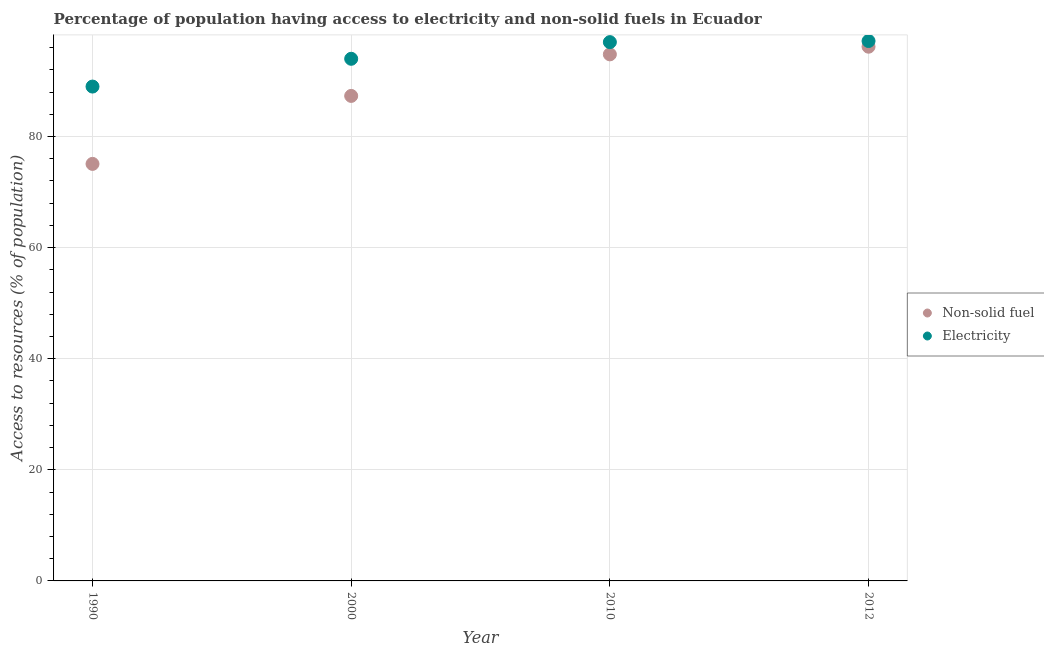How many different coloured dotlines are there?
Offer a terse response. 2. What is the percentage of population having access to non-solid fuel in 2010?
Offer a terse response. 94.8. Across all years, what is the maximum percentage of population having access to electricity?
Keep it short and to the point. 97.2. Across all years, what is the minimum percentage of population having access to electricity?
Your response must be concise. 89. In which year was the percentage of population having access to electricity maximum?
Your answer should be compact. 2012. What is the total percentage of population having access to electricity in the graph?
Offer a very short reply. 377.2. What is the difference between the percentage of population having access to non-solid fuel in 1990 and that in 2010?
Provide a succinct answer. -19.72. What is the difference between the percentage of population having access to non-solid fuel in 2010 and the percentage of population having access to electricity in 2012?
Your answer should be compact. -2.4. What is the average percentage of population having access to non-solid fuel per year?
Keep it short and to the point. 88.34. In the year 2012, what is the difference between the percentage of population having access to non-solid fuel and percentage of population having access to electricity?
Provide a succinct answer. -1.02. In how many years, is the percentage of population having access to non-solid fuel greater than 44 %?
Your response must be concise. 4. What is the ratio of the percentage of population having access to electricity in 1990 to that in 2000?
Offer a terse response. 0.95. Is the difference between the percentage of population having access to electricity in 1990 and 2010 greater than the difference between the percentage of population having access to non-solid fuel in 1990 and 2010?
Your answer should be very brief. Yes. What is the difference between the highest and the second highest percentage of population having access to non-solid fuel?
Offer a terse response. 1.38. What is the difference between the highest and the lowest percentage of population having access to electricity?
Give a very brief answer. 8.2. Is the sum of the percentage of population having access to electricity in 1990 and 2000 greater than the maximum percentage of population having access to non-solid fuel across all years?
Make the answer very short. Yes. Does the percentage of population having access to non-solid fuel monotonically increase over the years?
Offer a very short reply. Yes. Is the percentage of population having access to non-solid fuel strictly greater than the percentage of population having access to electricity over the years?
Provide a short and direct response. No. Is the percentage of population having access to electricity strictly less than the percentage of population having access to non-solid fuel over the years?
Offer a terse response. No. How many dotlines are there?
Your response must be concise. 2. How many years are there in the graph?
Offer a terse response. 4. Does the graph contain any zero values?
Offer a terse response. No. Where does the legend appear in the graph?
Offer a terse response. Center right. What is the title of the graph?
Provide a short and direct response. Percentage of population having access to electricity and non-solid fuels in Ecuador. What is the label or title of the X-axis?
Your answer should be compact. Year. What is the label or title of the Y-axis?
Your response must be concise. Access to resources (% of population). What is the Access to resources (% of population) in Non-solid fuel in 1990?
Your answer should be very brief. 75.08. What is the Access to resources (% of population) of Electricity in 1990?
Ensure brevity in your answer.  89. What is the Access to resources (% of population) of Non-solid fuel in 2000?
Provide a succinct answer. 87.32. What is the Access to resources (% of population) of Electricity in 2000?
Your response must be concise. 94. What is the Access to resources (% of population) in Non-solid fuel in 2010?
Your answer should be compact. 94.8. What is the Access to resources (% of population) in Electricity in 2010?
Provide a short and direct response. 97. What is the Access to resources (% of population) of Non-solid fuel in 2012?
Offer a terse response. 96.18. What is the Access to resources (% of population) in Electricity in 2012?
Provide a succinct answer. 97.2. Across all years, what is the maximum Access to resources (% of population) in Non-solid fuel?
Give a very brief answer. 96.18. Across all years, what is the maximum Access to resources (% of population) in Electricity?
Your response must be concise. 97.2. Across all years, what is the minimum Access to resources (% of population) in Non-solid fuel?
Your response must be concise. 75.08. Across all years, what is the minimum Access to resources (% of population) of Electricity?
Offer a very short reply. 89. What is the total Access to resources (% of population) in Non-solid fuel in the graph?
Your response must be concise. 353.37. What is the total Access to resources (% of population) in Electricity in the graph?
Give a very brief answer. 377.2. What is the difference between the Access to resources (% of population) of Non-solid fuel in 1990 and that in 2000?
Offer a terse response. -12.24. What is the difference between the Access to resources (% of population) of Non-solid fuel in 1990 and that in 2010?
Your answer should be compact. -19.72. What is the difference between the Access to resources (% of population) of Non-solid fuel in 1990 and that in 2012?
Keep it short and to the point. -21.1. What is the difference between the Access to resources (% of population) in Non-solid fuel in 2000 and that in 2010?
Give a very brief answer. -7.48. What is the difference between the Access to resources (% of population) in Non-solid fuel in 2000 and that in 2012?
Make the answer very short. -8.86. What is the difference between the Access to resources (% of population) of Electricity in 2000 and that in 2012?
Your answer should be very brief. -3.2. What is the difference between the Access to resources (% of population) of Non-solid fuel in 2010 and that in 2012?
Your answer should be very brief. -1.38. What is the difference between the Access to resources (% of population) in Electricity in 2010 and that in 2012?
Make the answer very short. -0.2. What is the difference between the Access to resources (% of population) in Non-solid fuel in 1990 and the Access to resources (% of population) in Electricity in 2000?
Provide a succinct answer. -18.92. What is the difference between the Access to resources (% of population) in Non-solid fuel in 1990 and the Access to resources (% of population) in Electricity in 2010?
Your response must be concise. -21.92. What is the difference between the Access to resources (% of population) of Non-solid fuel in 1990 and the Access to resources (% of population) of Electricity in 2012?
Your response must be concise. -22.12. What is the difference between the Access to resources (% of population) in Non-solid fuel in 2000 and the Access to resources (% of population) in Electricity in 2010?
Your response must be concise. -9.68. What is the difference between the Access to resources (% of population) of Non-solid fuel in 2000 and the Access to resources (% of population) of Electricity in 2012?
Make the answer very short. -9.88. What is the difference between the Access to resources (% of population) in Non-solid fuel in 2010 and the Access to resources (% of population) in Electricity in 2012?
Keep it short and to the point. -2.4. What is the average Access to resources (% of population) of Non-solid fuel per year?
Offer a terse response. 88.34. What is the average Access to resources (% of population) of Electricity per year?
Provide a short and direct response. 94.3. In the year 1990, what is the difference between the Access to resources (% of population) of Non-solid fuel and Access to resources (% of population) of Electricity?
Your answer should be compact. -13.92. In the year 2000, what is the difference between the Access to resources (% of population) of Non-solid fuel and Access to resources (% of population) of Electricity?
Offer a terse response. -6.68. In the year 2010, what is the difference between the Access to resources (% of population) in Non-solid fuel and Access to resources (% of population) in Electricity?
Ensure brevity in your answer.  -2.2. In the year 2012, what is the difference between the Access to resources (% of population) in Non-solid fuel and Access to resources (% of population) in Electricity?
Ensure brevity in your answer.  -1.02. What is the ratio of the Access to resources (% of population) of Non-solid fuel in 1990 to that in 2000?
Provide a short and direct response. 0.86. What is the ratio of the Access to resources (% of population) in Electricity in 1990 to that in 2000?
Your answer should be compact. 0.95. What is the ratio of the Access to resources (% of population) of Non-solid fuel in 1990 to that in 2010?
Offer a very short reply. 0.79. What is the ratio of the Access to resources (% of population) of Electricity in 1990 to that in 2010?
Provide a short and direct response. 0.92. What is the ratio of the Access to resources (% of population) of Non-solid fuel in 1990 to that in 2012?
Provide a succinct answer. 0.78. What is the ratio of the Access to resources (% of population) in Electricity in 1990 to that in 2012?
Your answer should be compact. 0.92. What is the ratio of the Access to resources (% of population) of Non-solid fuel in 2000 to that in 2010?
Offer a terse response. 0.92. What is the ratio of the Access to resources (% of population) in Electricity in 2000 to that in 2010?
Provide a short and direct response. 0.97. What is the ratio of the Access to resources (% of population) of Non-solid fuel in 2000 to that in 2012?
Keep it short and to the point. 0.91. What is the ratio of the Access to resources (% of population) of Electricity in 2000 to that in 2012?
Your answer should be compact. 0.97. What is the ratio of the Access to resources (% of population) in Non-solid fuel in 2010 to that in 2012?
Your answer should be very brief. 0.99. What is the difference between the highest and the second highest Access to resources (% of population) in Non-solid fuel?
Provide a short and direct response. 1.38. What is the difference between the highest and the lowest Access to resources (% of population) in Non-solid fuel?
Provide a short and direct response. 21.1. 